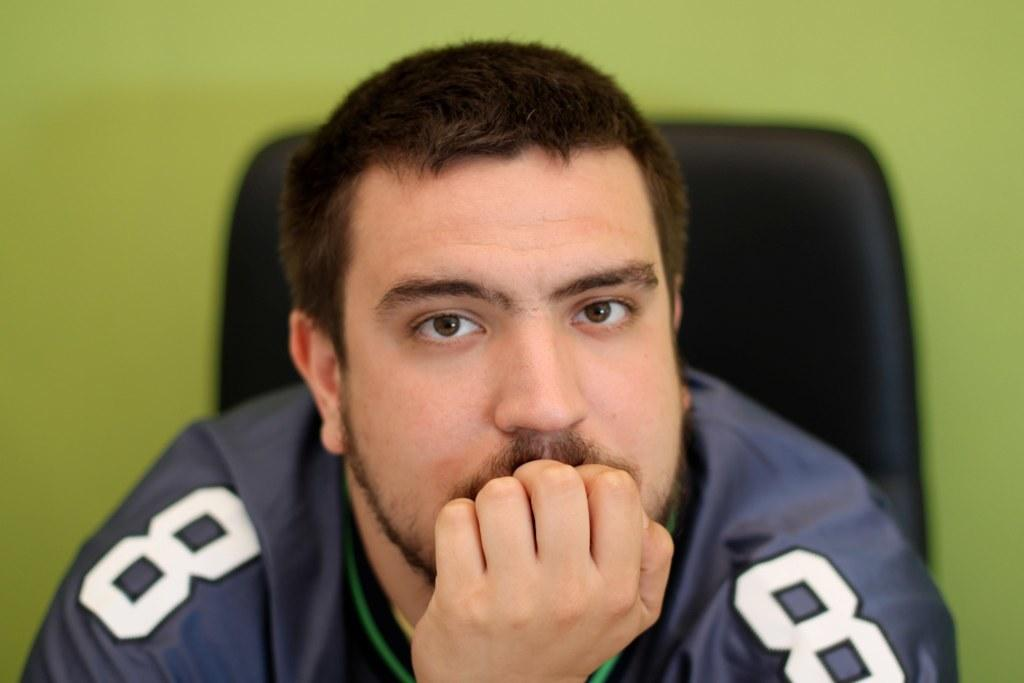<image>
Describe the image concisely. A man in a blue and green jersey with the number 8 on it 